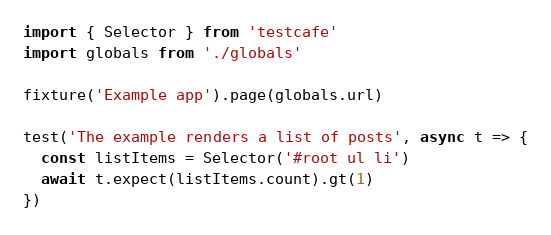<code> <loc_0><loc_0><loc_500><loc_500><_JavaScript_>import { Selector } from 'testcafe'
import globals from './globals'

fixture('Example app').page(globals.url)

test('The example renders a list of posts', async t => {
  const listItems = Selector('#root ul li')
  await t.expect(listItems.count).gt(1)
})
</code> 